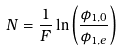<formula> <loc_0><loc_0><loc_500><loc_500>N = \frac { 1 } { F } \ln \left ( \frac { \phi _ { 1 , 0 } } { \phi _ { 1 , e } } \right )</formula> 